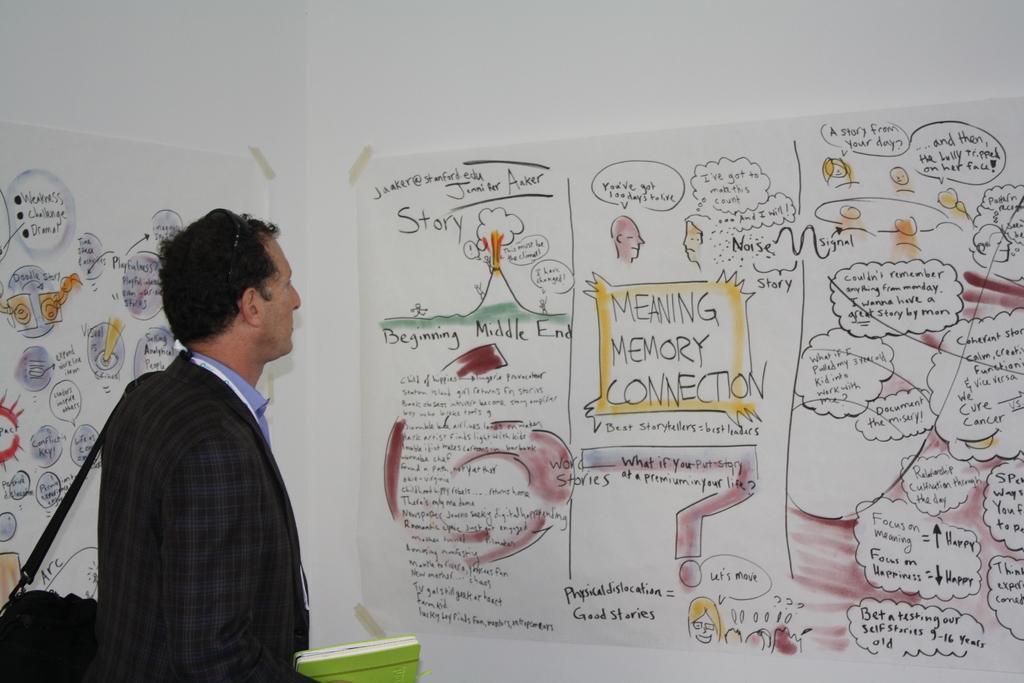<image>
Offer a succinct explanation of the picture presented. One of the drawing supports Meaning Memory Connections. 